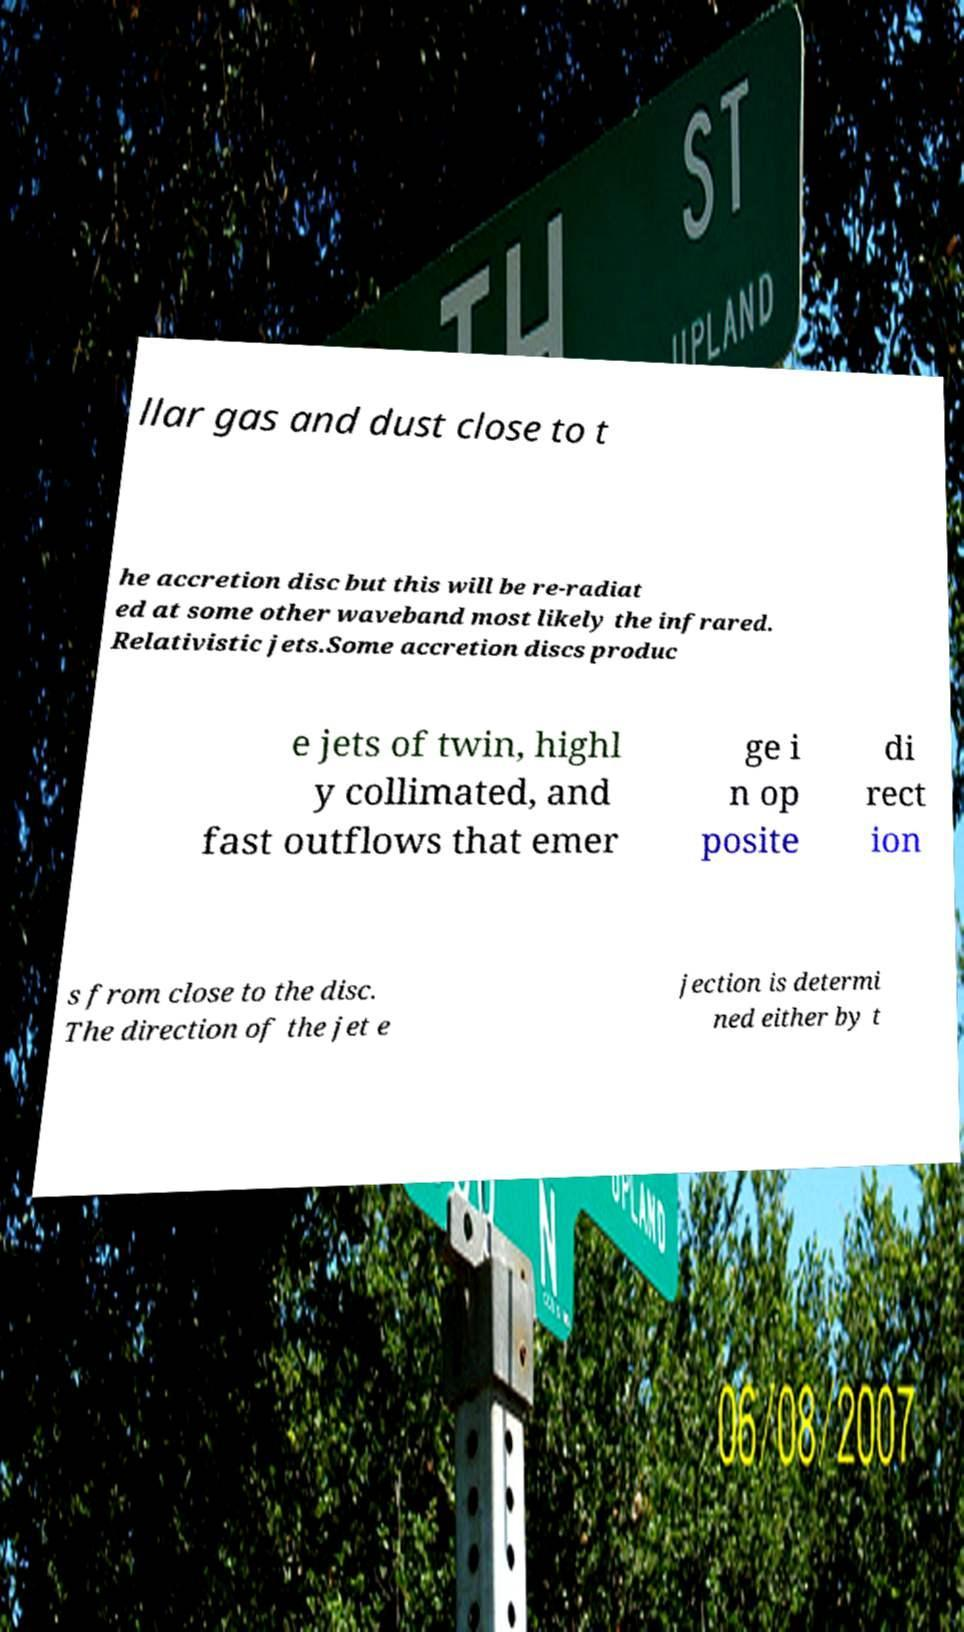Please identify and transcribe the text found in this image. llar gas and dust close to t he accretion disc but this will be re-radiat ed at some other waveband most likely the infrared. Relativistic jets.Some accretion discs produc e jets of twin, highl y collimated, and fast outflows that emer ge i n op posite di rect ion s from close to the disc. The direction of the jet e jection is determi ned either by t 